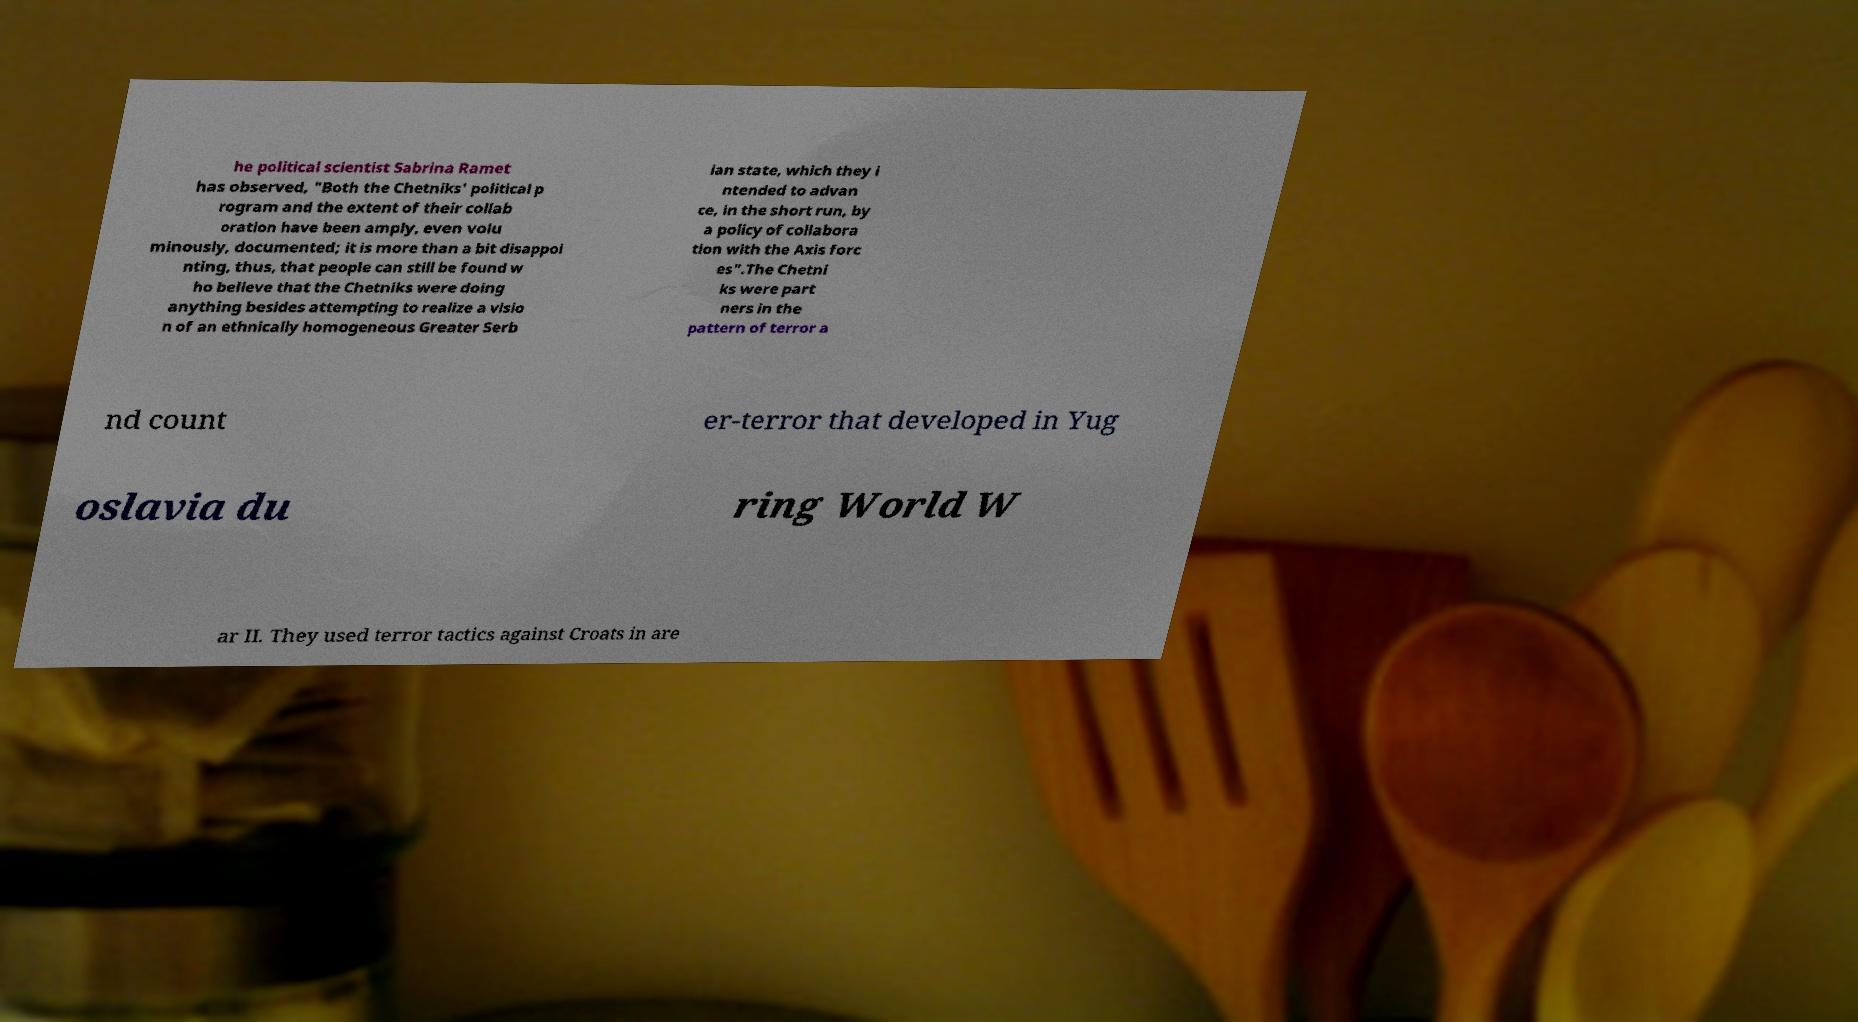For documentation purposes, I need the text within this image transcribed. Could you provide that? he political scientist Sabrina Ramet has observed, "Both the Chetniks' political p rogram and the extent of their collab oration have been amply, even volu minously, documented; it is more than a bit disappoi nting, thus, that people can still be found w ho believe that the Chetniks were doing anything besides attempting to realize a visio n of an ethnically homogeneous Greater Serb ian state, which they i ntended to advan ce, in the short run, by a policy of collabora tion with the Axis forc es".The Chetni ks were part ners in the pattern of terror a nd count er-terror that developed in Yug oslavia du ring World W ar II. They used terror tactics against Croats in are 